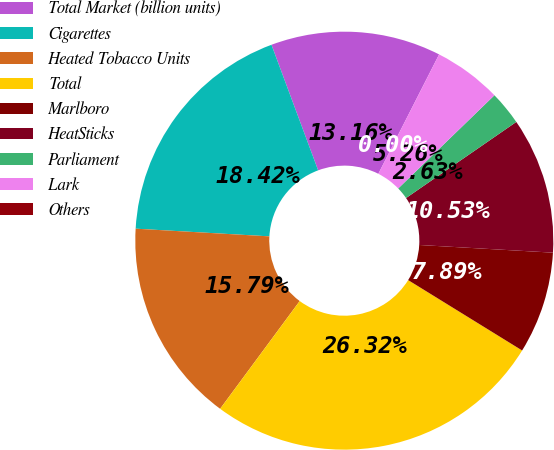Convert chart. <chart><loc_0><loc_0><loc_500><loc_500><pie_chart><fcel>Total Market (billion units)<fcel>Cigarettes<fcel>Heated Tobacco Units<fcel>Total<fcel>Marlboro<fcel>HeatSticks<fcel>Parliament<fcel>Lark<fcel>Others<nl><fcel>13.16%<fcel>18.42%<fcel>15.79%<fcel>26.32%<fcel>7.89%<fcel>10.53%<fcel>2.63%<fcel>5.26%<fcel>0.0%<nl></chart> 